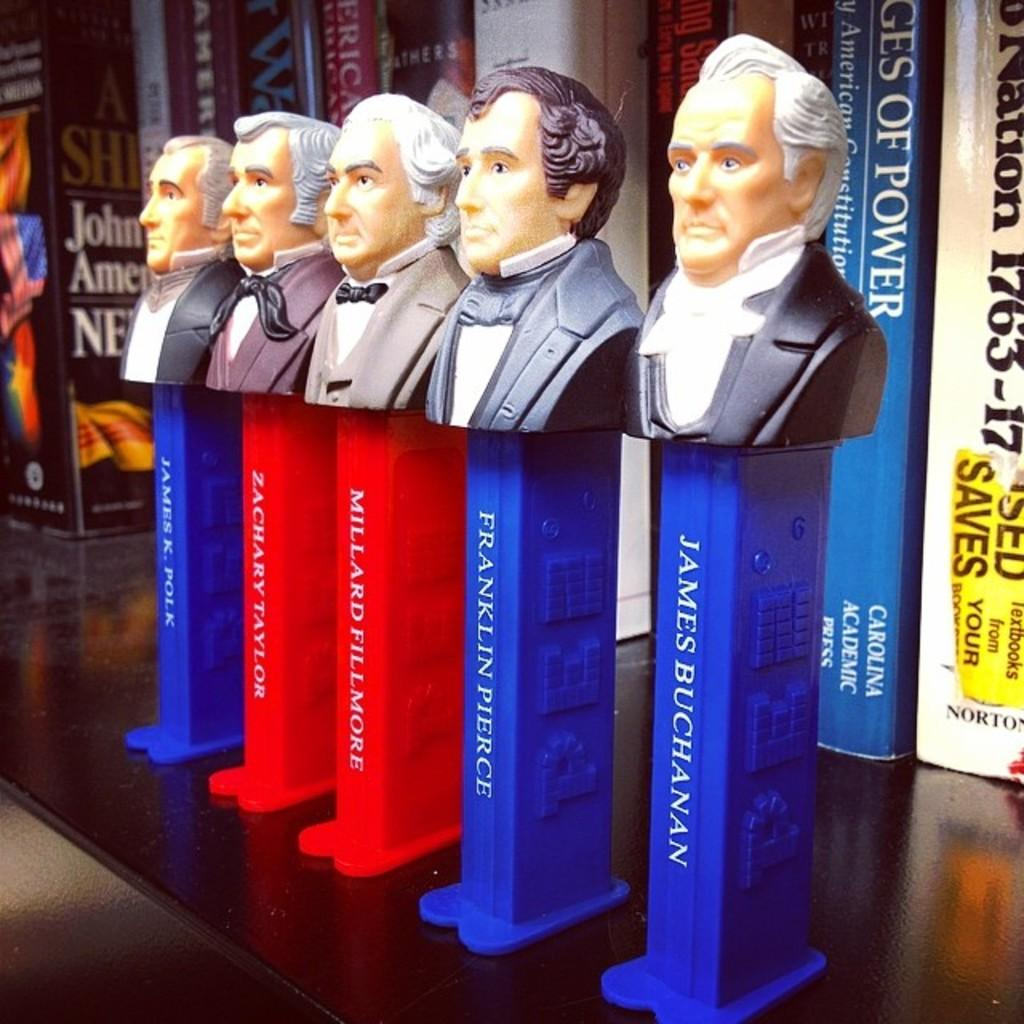<image>
Give a short and clear explanation of the subsequent image. A stack of Pez dispensers with images of President's head on them. 